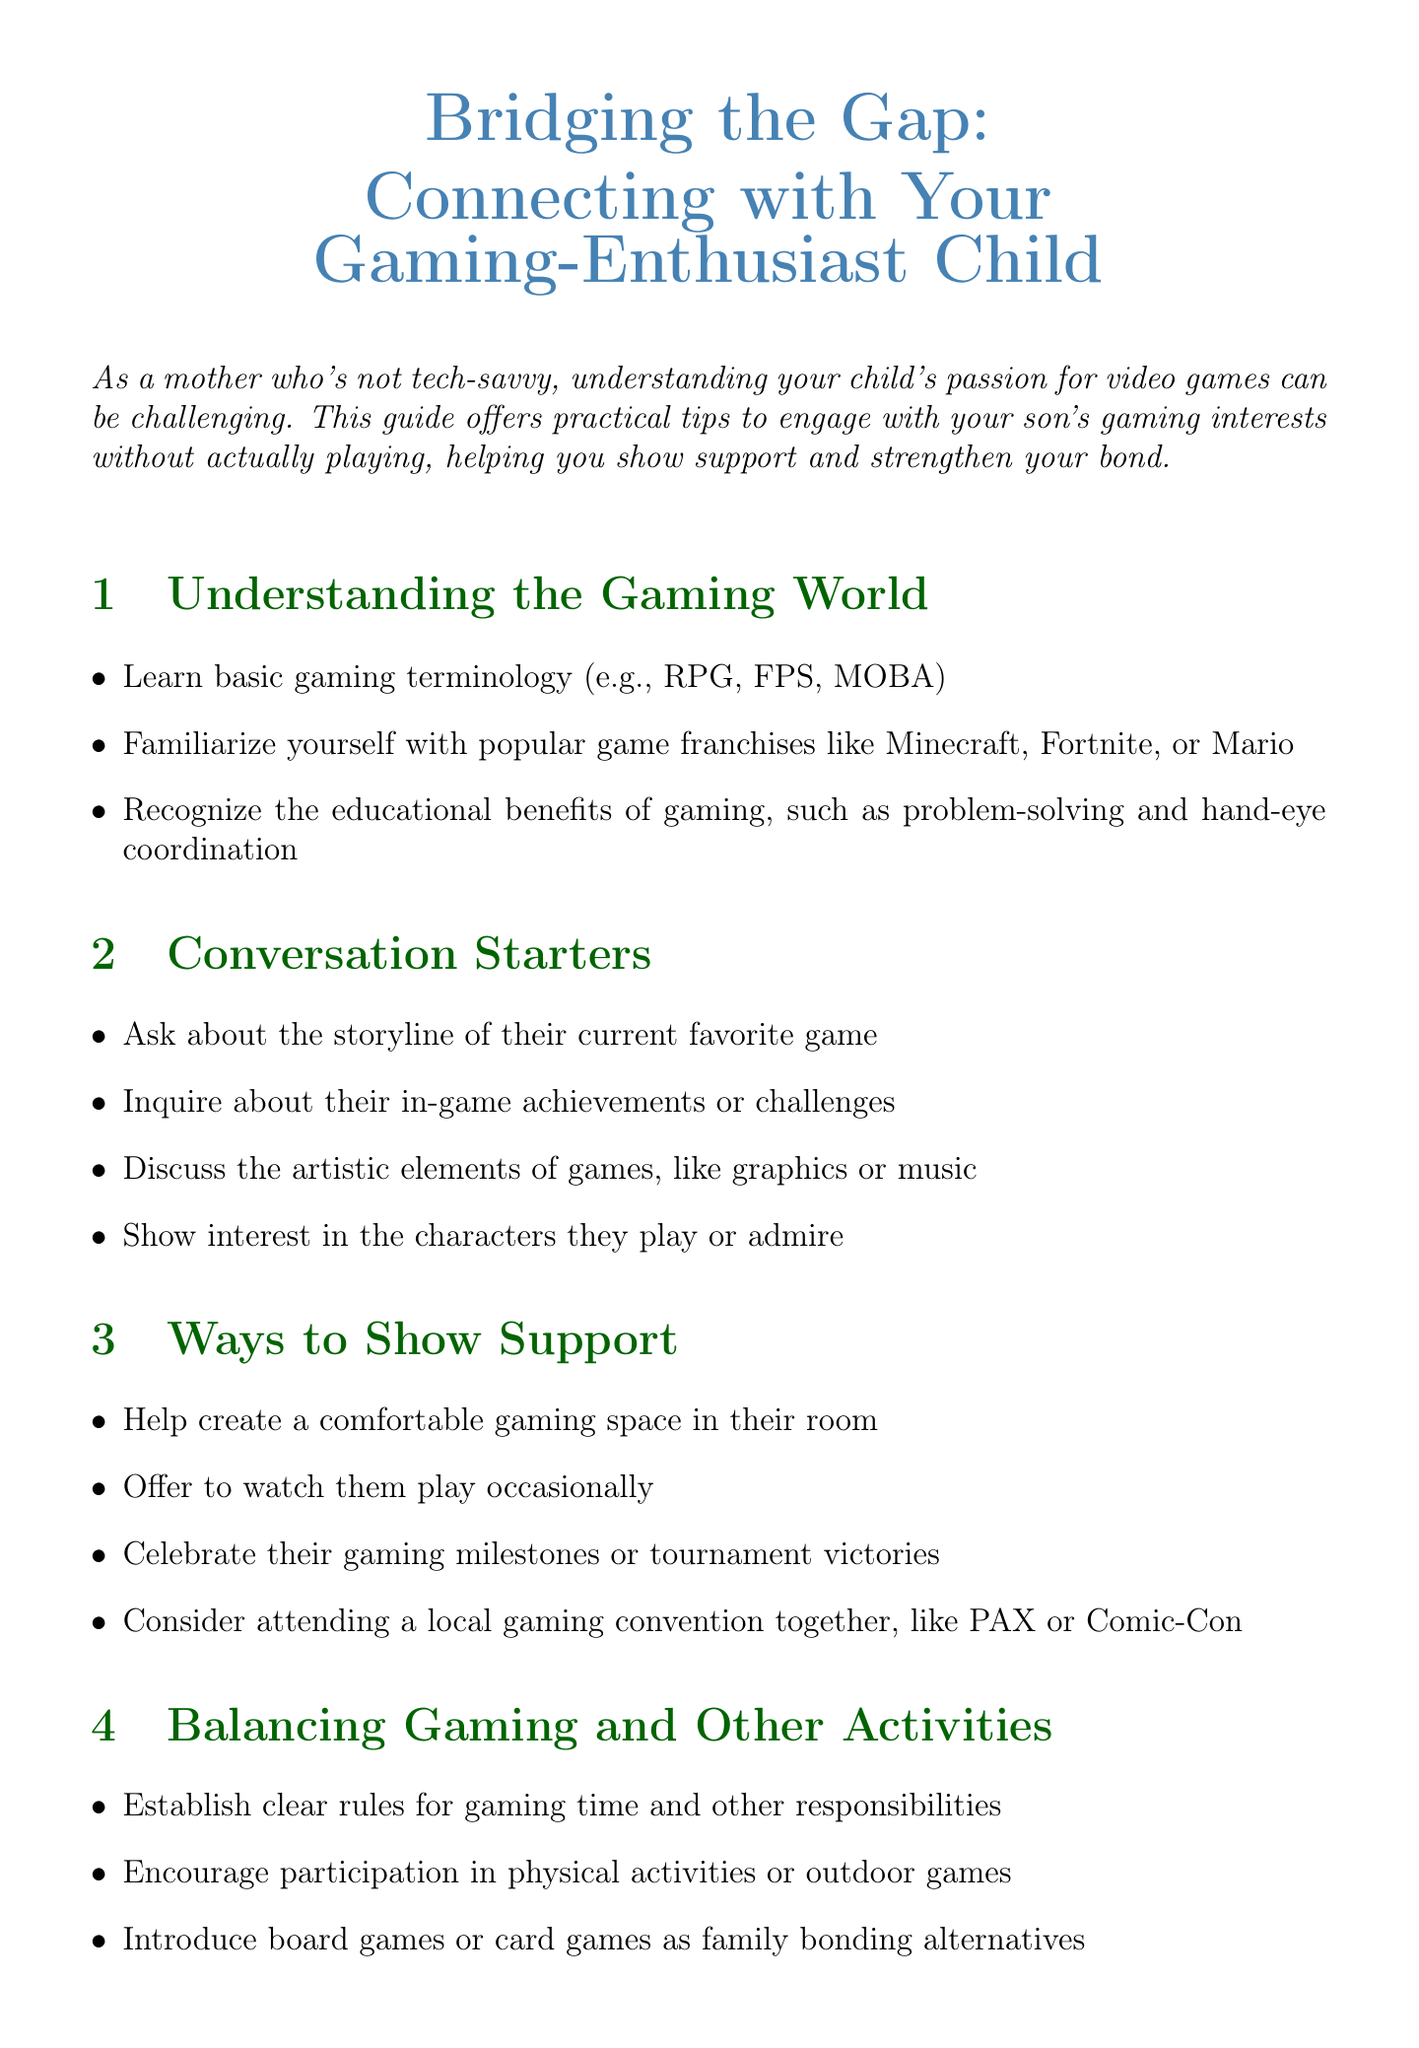What is the title of the document? The title is displayed at the beginning and summarizes the document's purpose.
Answer: Bridging the Gap: Connecting with Your Gaming-Enthusiast Child How many sections are there in the document? The document has a list of structured sections, each covering different topics.
Answer: Six What gaming franchise is mentioned as a popular example? The document lists popular franchises to help mothers understand their child's interests.
Answer: Minecraft What is one role of gaming according to the document? The document mentions the benefits of gaming, indicating its positive impact.
Answer: Problem-solving What does the document suggest for celebrating gaming milestones? The document provides specific suggestions for supporting a child's gaming achievements.
Answer: Celebrate their gaming milestones or tournament victories Which gaming convention is mentioned in the support section? Specific conventions are recommended for mothers to consider attending with their child.
Answer: PAX or Comic-Con What are parents encouraged to learn about regarding online games? The document offers advice to help ensure children's safety while gaming.
Answer: Online safety What type of activities does the document suggest alongside gaming? The document encourages balance by suggesting alternatives to gaming.
Answer: Physical activities or outdoor games 